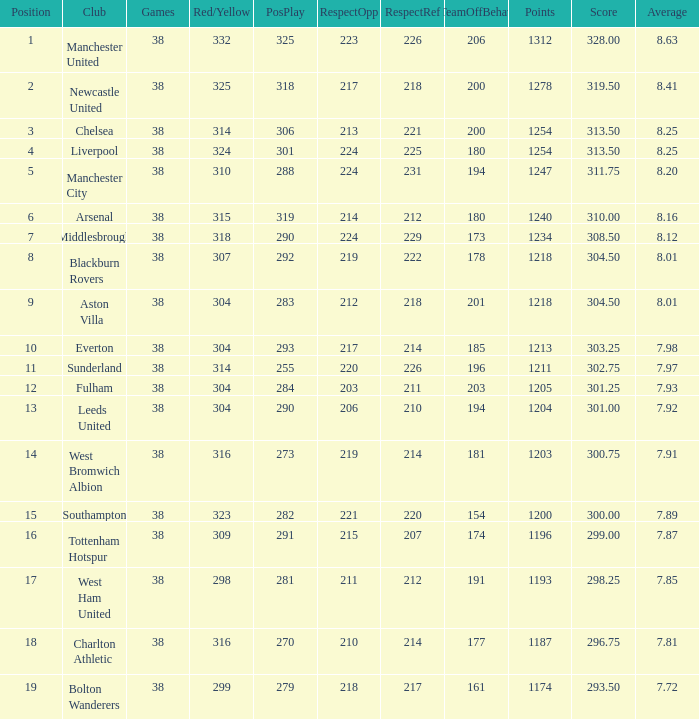Name the most pos for west bromwich albion club 14.0. 